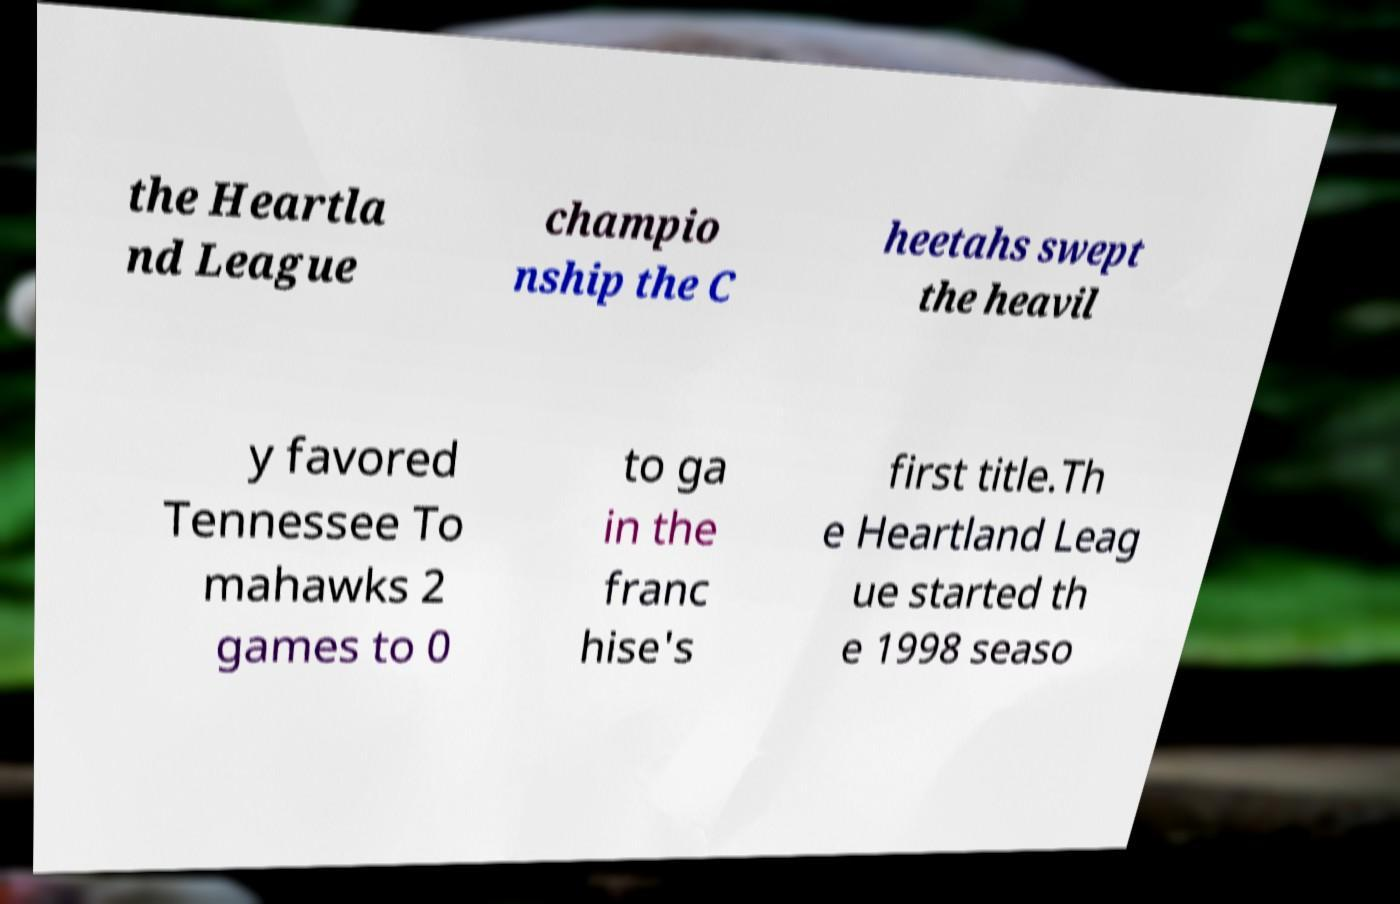Can you accurately transcribe the text from the provided image for me? the Heartla nd League champio nship the C heetahs swept the heavil y favored Tennessee To mahawks 2 games to 0 to ga in the franc hise's first title.Th e Heartland Leag ue started th e 1998 seaso 